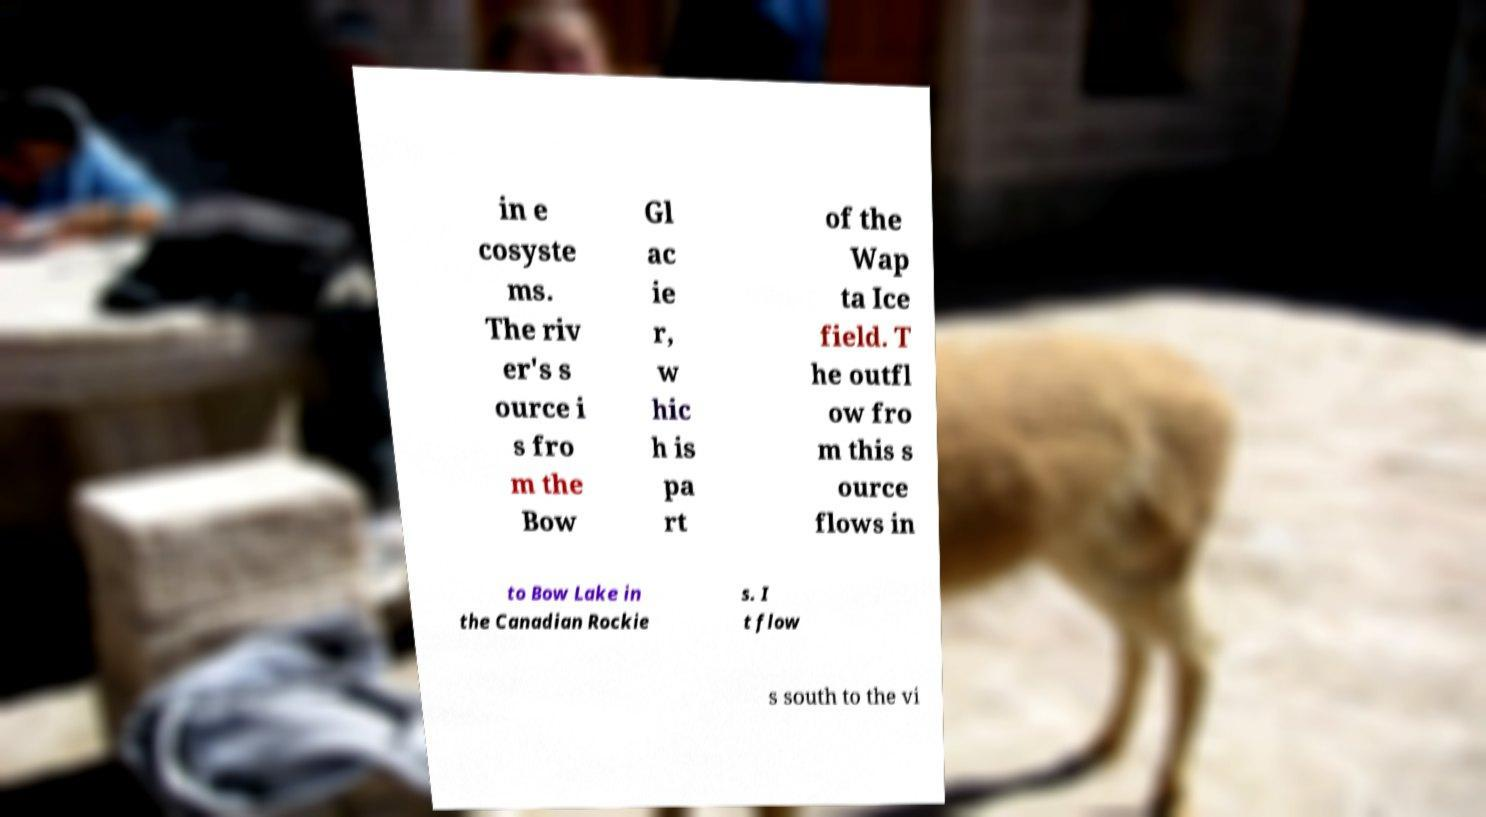Can you read and provide the text displayed in the image?This photo seems to have some interesting text. Can you extract and type it out for me? in e cosyste ms. The riv er's s ource i s fro m the Bow Gl ac ie r, w hic h is pa rt of the Wap ta Ice field. T he outfl ow fro m this s ource flows in to Bow Lake in the Canadian Rockie s. I t flow s south to the vi 